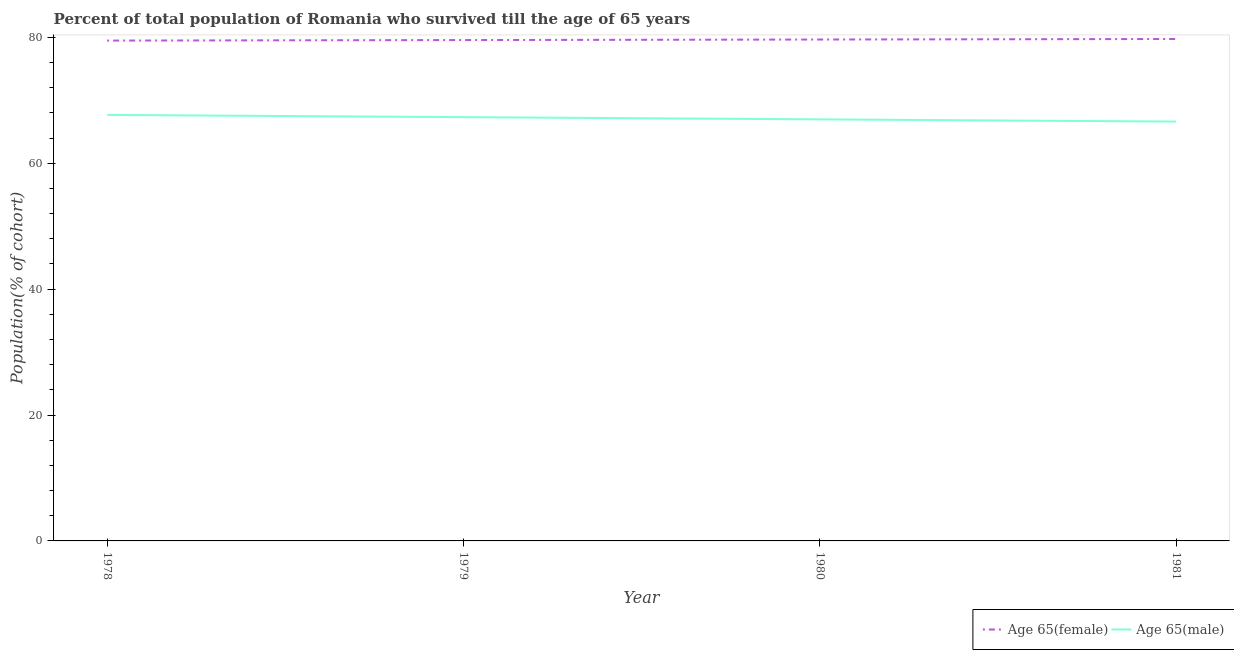Does the line corresponding to percentage of male population who survived till age of 65 intersect with the line corresponding to percentage of female population who survived till age of 65?
Provide a succinct answer. No. Is the number of lines equal to the number of legend labels?
Ensure brevity in your answer.  Yes. What is the percentage of male population who survived till age of 65 in 1980?
Offer a very short reply. 66.98. Across all years, what is the maximum percentage of female population who survived till age of 65?
Give a very brief answer. 79.74. Across all years, what is the minimum percentage of female population who survived till age of 65?
Offer a terse response. 79.49. In which year was the percentage of male population who survived till age of 65 maximum?
Offer a terse response. 1978. What is the total percentage of male population who survived till age of 65 in the graph?
Give a very brief answer. 268.61. What is the difference between the percentage of male population who survived till age of 65 in 1980 and that in 1981?
Ensure brevity in your answer.  0.35. What is the difference between the percentage of female population who survived till age of 65 in 1979 and the percentage of male population who survived till age of 65 in 1981?
Make the answer very short. 12.95. What is the average percentage of male population who survived till age of 65 per year?
Your answer should be very brief. 67.15. In the year 1979, what is the difference between the percentage of female population who survived till age of 65 and percentage of male population who survived till age of 65?
Your answer should be compact. 12.25. In how many years, is the percentage of male population who survived till age of 65 greater than 20 %?
Your answer should be very brief. 4. What is the ratio of the percentage of male population who survived till age of 65 in 1978 to that in 1979?
Give a very brief answer. 1.01. Is the percentage of male population who survived till age of 65 in 1978 less than that in 1981?
Your answer should be compact. No. What is the difference between the highest and the second highest percentage of male population who survived till age of 65?
Give a very brief answer. 0.35. What is the difference between the highest and the lowest percentage of female population who survived till age of 65?
Provide a short and direct response. 0.25. In how many years, is the percentage of female population who survived till age of 65 greater than the average percentage of female population who survived till age of 65 taken over all years?
Your answer should be very brief. 2. Is the percentage of female population who survived till age of 65 strictly less than the percentage of male population who survived till age of 65 over the years?
Provide a short and direct response. No. How many years are there in the graph?
Give a very brief answer. 4. What is the difference between two consecutive major ticks on the Y-axis?
Your answer should be compact. 20. Does the graph contain any zero values?
Ensure brevity in your answer.  No. How many legend labels are there?
Your answer should be compact. 2. How are the legend labels stacked?
Provide a short and direct response. Horizontal. What is the title of the graph?
Provide a short and direct response. Percent of total population of Romania who survived till the age of 65 years. What is the label or title of the X-axis?
Your answer should be very brief. Year. What is the label or title of the Y-axis?
Your answer should be very brief. Population(% of cohort). What is the Population(% of cohort) of Age 65(female) in 1978?
Ensure brevity in your answer.  79.49. What is the Population(% of cohort) of Age 65(male) in 1978?
Give a very brief answer. 67.68. What is the Population(% of cohort) of Age 65(female) in 1979?
Your answer should be compact. 79.58. What is the Population(% of cohort) of Age 65(male) in 1979?
Ensure brevity in your answer.  67.33. What is the Population(% of cohort) of Age 65(female) in 1980?
Your answer should be very brief. 79.66. What is the Population(% of cohort) of Age 65(male) in 1980?
Provide a succinct answer. 66.98. What is the Population(% of cohort) of Age 65(female) in 1981?
Offer a terse response. 79.74. What is the Population(% of cohort) of Age 65(male) in 1981?
Your response must be concise. 66.62. Across all years, what is the maximum Population(% of cohort) in Age 65(female)?
Provide a short and direct response. 79.74. Across all years, what is the maximum Population(% of cohort) in Age 65(male)?
Offer a very short reply. 67.68. Across all years, what is the minimum Population(% of cohort) of Age 65(female)?
Give a very brief answer. 79.49. Across all years, what is the minimum Population(% of cohort) of Age 65(male)?
Your answer should be compact. 66.62. What is the total Population(% of cohort) of Age 65(female) in the graph?
Provide a succinct answer. 318.47. What is the total Population(% of cohort) of Age 65(male) in the graph?
Your response must be concise. 268.61. What is the difference between the Population(% of cohort) in Age 65(female) in 1978 and that in 1979?
Make the answer very short. -0.08. What is the difference between the Population(% of cohort) in Age 65(male) in 1978 and that in 1979?
Your answer should be compact. 0.35. What is the difference between the Population(% of cohort) in Age 65(female) in 1978 and that in 1980?
Provide a short and direct response. -0.17. What is the difference between the Population(% of cohort) in Age 65(male) in 1978 and that in 1980?
Your response must be concise. 0.71. What is the difference between the Population(% of cohort) of Age 65(female) in 1978 and that in 1981?
Offer a very short reply. -0.25. What is the difference between the Population(% of cohort) of Age 65(male) in 1978 and that in 1981?
Provide a short and direct response. 1.06. What is the difference between the Population(% of cohort) of Age 65(female) in 1979 and that in 1980?
Give a very brief answer. -0.08. What is the difference between the Population(% of cohort) in Age 65(male) in 1979 and that in 1980?
Ensure brevity in your answer.  0.35. What is the difference between the Population(% of cohort) in Age 65(female) in 1979 and that in 1981?
Ensure brevity in your answer.  -0.17. What is the difference between the Population(% of cohort) of Age 65(male) in 1979 and that in 1981?
Ensure brevity in your answer.  0.71. What is the difference between the Population(% of cohort) of Age 65(female) in 1980 and that in 1981?
Provide a short and direct response. -0.08. What is the difference between the Population(% of cohort) of Age 65(male) in 1980 and that in 1981?
Provide a succinct answer. 0.35. What is the difference between the Population(% of cohort) in Age 65(female) in 1978 and the Population(% of cohort) in Age 65(male) in 1979?
Provide a short and direct response. 12.16. What is the difference between the Population(% of cohort) in Age 65(female) in 1978 and the Population(% of cohort) in Age 65(male) in 1980?
Provide a succinct answer. 12.52. What is the difference between the Population(% of cohort) in Age 65(female) in 1978 and the Population(% of cohort) in Age 65(male) in 1981?
Your response must be concise. 12.87. What is the difference between the Population(% of cohort) of Age 65(female) in 1979 and the Population(% of cohort) of Age 65(male) in 1980?
Your answer should be compact. 12.6. What is the difference between the Population(% of cohort) of Age 65(female) in 1979 and the Population(% of cohort) of Age 65(male) in 1981?
Your answer should be very brief. 12.95. What is the difference between the Population(% of cohort) in Age 65(female) in 1980 and the Population(% of cohort) in Age 65(male) in 1981?
Ensure brevity in your answer.  13.04. What is the average Population(% of cohort) of Age 65(female) per year?
Your answer should be compact. 79.62. What is the average Population(% of cohort) of Age 65(male) per year?
Your answer should be very brief. 67.15. In the year 1978, what is the difference between the Population(% of cohort) of Age 65(female) and Population(% of cohort) of Age 65(male)?
Provide a short and direct response. 11.81. In the year 1979, what is the difference between the Population(% of cohort) of Age 65(female) and Population(% of cohort) of Age 65(male)?
Offer a very short reply. 12.25. In the year 1980, what is the difference between the Population(% of cohort) in Age 65(female) and Population(% of cohort) in Age 65(male)?
Ensure brevity in your answer.  12.68. In the year 1981, what is the difference between the Population(% of cohort) of Age 65(female) and Population(% of cohort) of Age 65(male)?
Your response must be concise. 13.12. What is the ratio of the Population(% of cohort) in Age 65(male) in 1978 to that in 1979?
Your response must be concise. 1.01. What is the ratio of the Population(% of cohort) of Age 65(male) in 1978 to that in 1980?
Offer a terse response. 1.01. What is the ratio of the Population(% of cohort) of Age 65(female) in 1978 to that in 1981?
Your answer should be compact. 1. What is the ratio of the Population(% of cohort) in Age 65(male) in 1978 to that in 1981?
Your answer should be compact. 1.02. What is the ratio of the Population(% of cohort) in Age 65(male) in 1979 to that in 1980?
Provide a succinct answer. 1.01. What is the ratio of the Population(% of cohort) of Age 65(female) in 1979 to that in 1981?
Ensure brevity in your answer.  1. What is the ratio of the Population(% of cohort) in Age 65(male) in 1979 to that in 1981?
Ensure brevity in your answer.  1.01. What is the ratio of the Population(% of cohort) in Age 65(male) in 1980 to that in 1981?
Your answer should be very brief. 1.01. What is the difference between the highest and the second highest Population(% of cohort) of Age 65(female)?
Your answer should be very brief. 0.08. What is the difference between the highest and the second highest Population(% of cohort) of Age 65(male)?
Ensure brevity in your answer.  0.35. What is the difference between the highest and the lowest Population(% of cohort) in Age 65(female)?
Give a very brief answer. 0.25. What is the difference between the highest and the lowest Population(% of cohort) of Age 65(male)?
Keep it short and to the point. 1.06. 